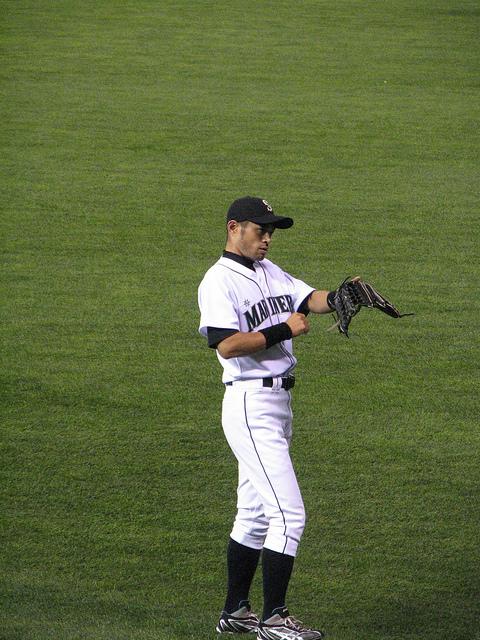What is the man doing?
Be succinct. Playing baseball. Is this player about to swing?
Be succinct. No. What type of shoes is the man wearing?
Give a very brief answer. Cleats. Is the athlete left or right handed?
Short answer required. Right. What is the man's dominant hand?
Be succinct. Right. Does he have a belt?
Concise answer only. Yes. What is the baseball player holding in the left hand?
Write a very short answer. Glove. Is the player's uniform dirty?
Answer briefly. No. What color are the players shoes?
Be succinct. Gray. What is he holding?
Keep it brief. Glove. What is the team name?
Quick response, please. Mariners. 